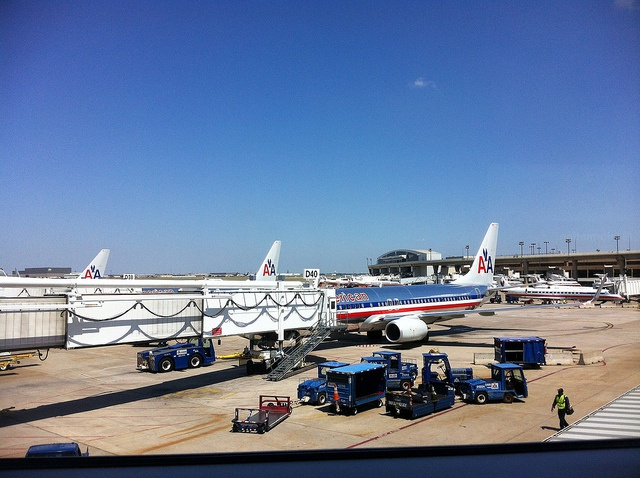Describe the objects in this image and their specific colors. I can see airplane in navy, white, darkgray, gray, and black tones, truck in navy, black, gray, and darkgray tones, truck in navy, black, lightblue, and gray tones, truck in navy, black, gray, and maroon tones, and truck in navy, black, gray, and blue tones in this image. 